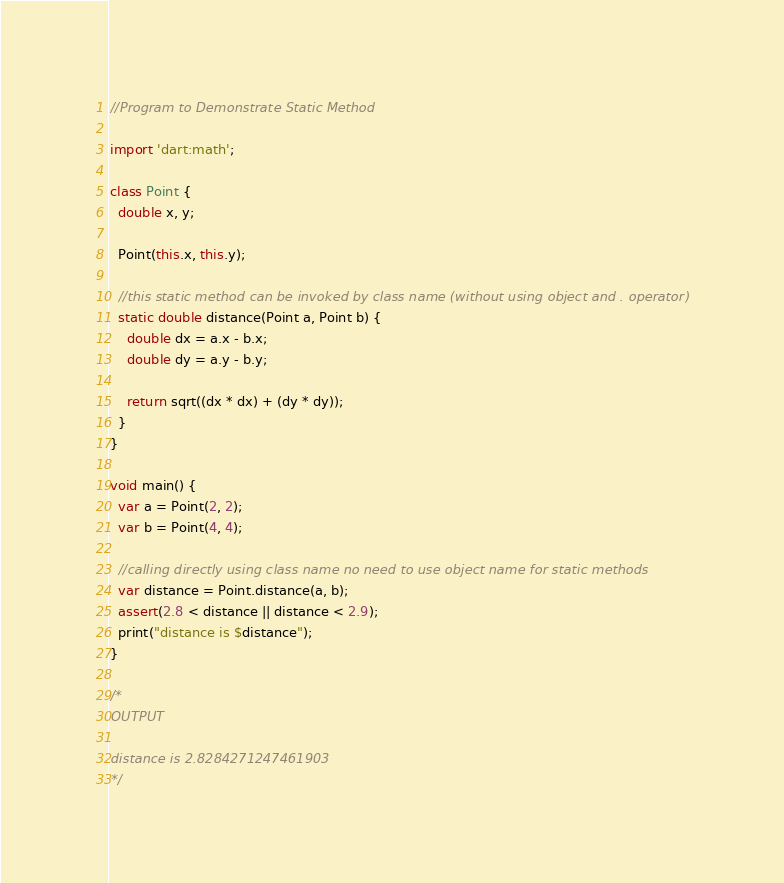Convert code to text. <code><loc_0><loc_0><loc_500><loc_500><_Dart_>//Program to Demonstrate Static Method

import 'dart:math';

class Point {
  double x, y;

  Point(this.x, this.y);

  //this static method can be invoked by class name (without using object and . operator)
  static double distance(Point a, Point b) {
    double dx = a.x - b.x;
    double dy = a.y - b.y;

    return sqrt((dx * dx) + (dy * dy));
  }
}

void main() {
  var a = Point(2, 2);
  var b = Point(4, 4);

  //calling directly using class name no need to use object name for static methods
  var distance = Point.distance(a, b);
  assert(2.8 < distance || distance < 2.9);
  print("distance is $distance");
}

/*
OUTPUT

distance is 2.8284271247461903
*/
</code> 